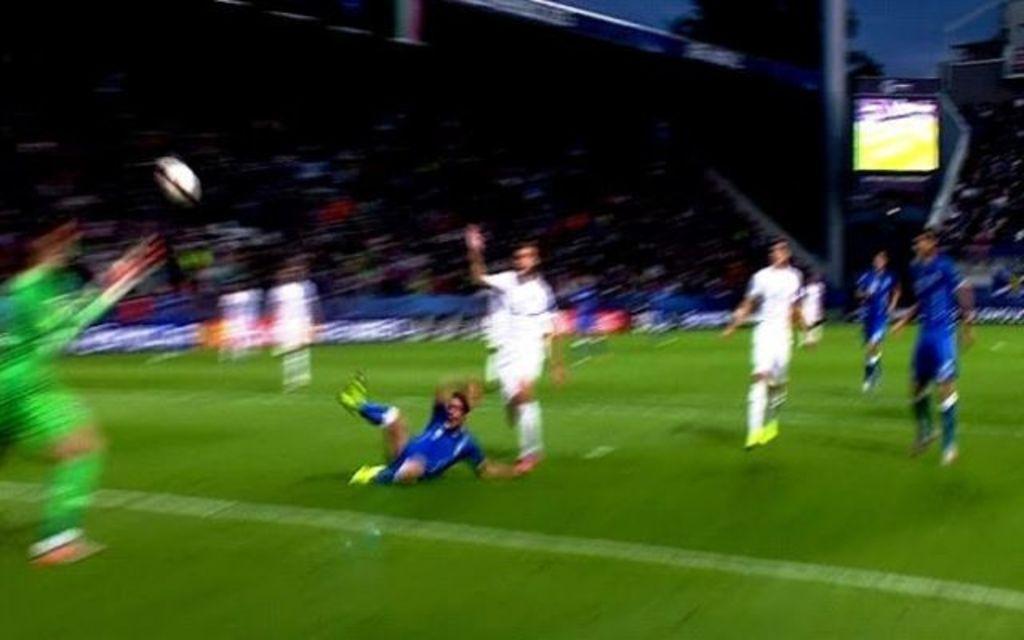Please provide a concise description of this image. Here we can see few people are playing on the ground and there is a ball. In the background we can see crowd, pole, screen, hoardings, trees, and sky. 